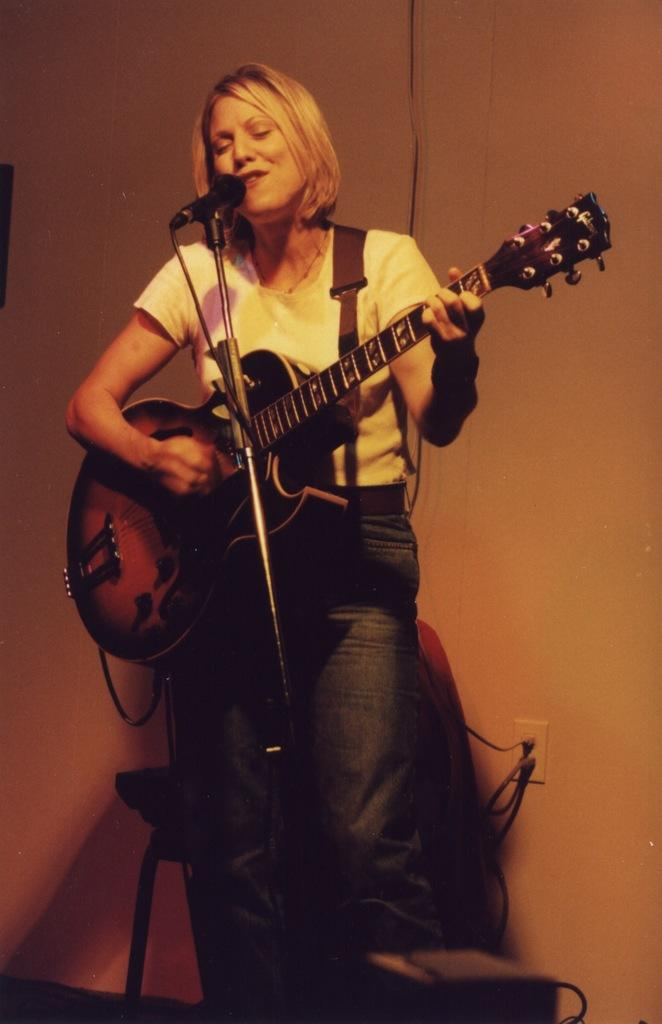Who is the main subject in the image? There is a woman in the image. What is the woman holding in the image? The woman is holding a guitar. What is the woman standing in front of in the image? The woman is standing in front of a microphone. What can be seen in the background of the image? There is a wall in the background of the image. How many mint leaves are on the woman's head in the image? There are no mint leaves present in the image. What time of day is depicted in the image? The provided facts do not give any information about the time of day, so it cannot be determined from the image. 